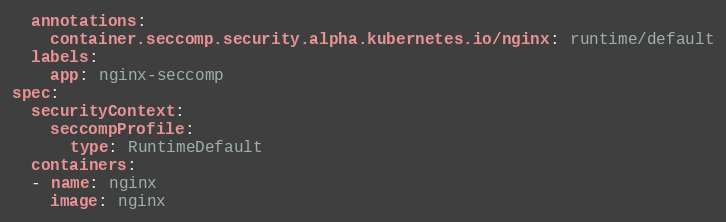Convert code to text. <code><loc_0><loc_0><loc_500><loc_500><_YAML_>  annotations:
    container.seccomp.security.alpha.kubernetes.io/nginx: runtime/default
  labels:
    app: nginx-seccomp
spec:
  securityContext:
    seccompProfile:
      type: RuntimeDefault
  containers:
  - name: nginx
    image: nginx
</code> 